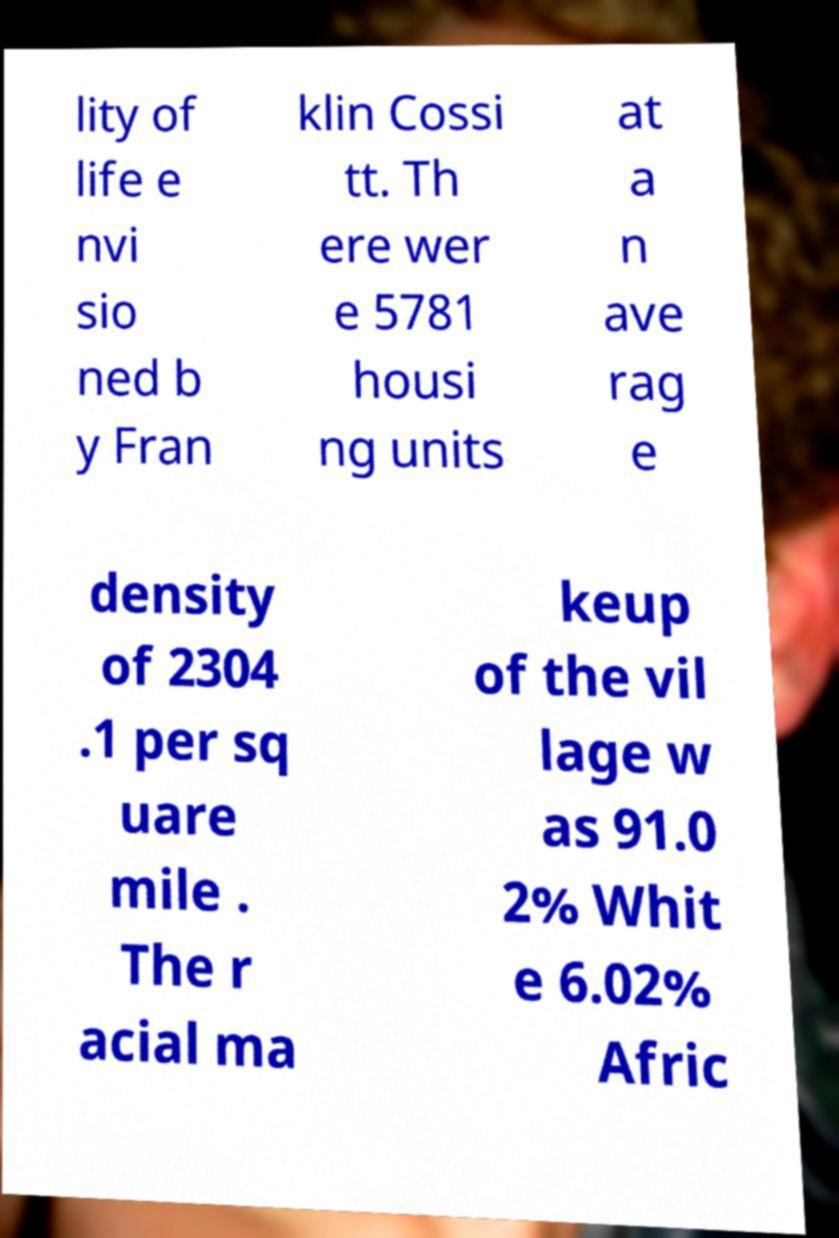Could you assist in decoding the text presented in this image and type it out clearly? lity of life e nvi sio ned b y Fran klin Cossi tt. Th ere wer e 5781 housi ng units at a n ave rag e density of 2304 .1 per sq uare mile . The r acial ma keup of the vil lage w as 91.0 2% Whit e 6.02% Afric 